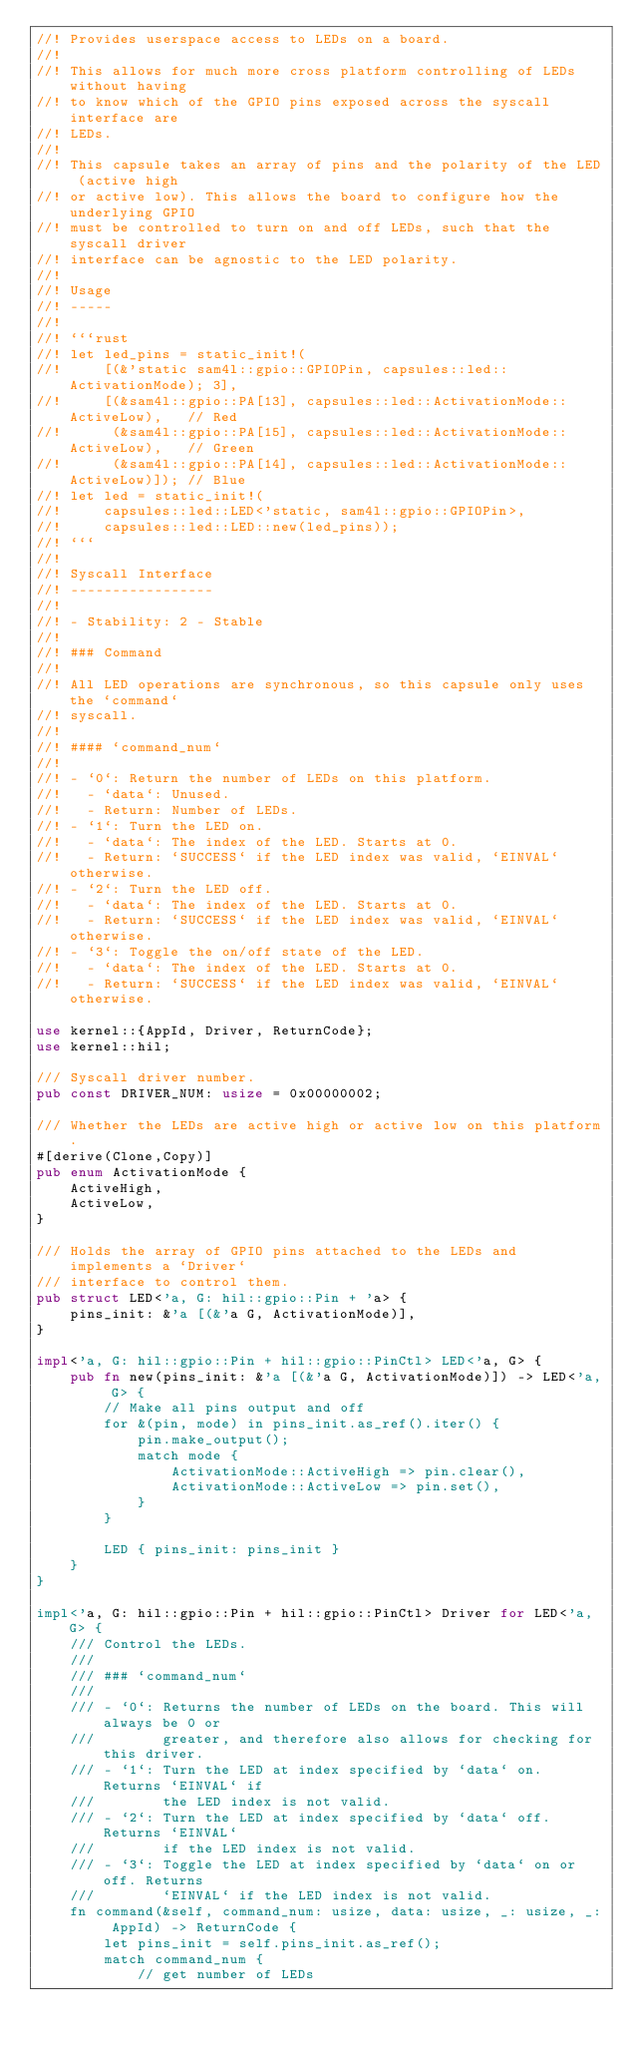Convert code to text. <code><loc_0><loc_0><loc_500><loc_500><_Rust_>//! Provides userspace access to LEDs on a board.
//!
//! This allows for much more cross platform controlling of LEDs without having
//! to know which of the GPIO pins exposed across the syscall interface are
//! LEDs.
//!
//! This capsule takes an array of pins and the polarity of the LED (active high
//! or active low). This allows the board to configure how the underlying GPIO
//! must be controlled to turn on and off LEDs, such that the syscall driver
//! interface can be agnostic to the LED polarity.
//!
//! Usage
//! -----
//!
//! ```rust
//! let led_pins = static_init!(
//!     [(&'static sam4l::gpio::GPIOPin, capsules::led::ActivationMode); 3],
//!     [(&sam4l::gpio::PA[13], capsules::led::ActivationMode::ActiveLow),   // Red
//!      (&sam4l::gpio::PA[15], capsules::led::ActivationMode::ActiveLow),   // Green
//!      (&sam4l::gpio::PA[14], capsules::led::ActivationMode::ActiveLow)]); // Blue
//! let led = static_init!(
//!     capsules::led::LED<'static, sam4l::gpio::GPIOPin>,
//!     capsules::led::LED::new(led_pins));
//! ```
//!
//! Syscall Interface
//! -----------------
//!
//! - Stability: 2 - Stable
//!
//! ### Command
//!
//! All LED operations are synchronous, so this capsule only uses the `command`
//! syscall.
//!
//! #### `command_num`
//!
//! - `0`: Return the number of LEDs on this platform.
//!   - `data`: Unused.
//!   - Return: Number of LEDs.
//! - `1`: Turn the LED on.
//!   - `data`: The index of the LED. Starts at 0.
//!   - Return: `SUCCESS` if the LED index was valid, `EINVAL` otherwise.
//! - `2`: Turn the LED off.
//!   - `data`: The index of the LED. Starts at 0.
//!   - Return: `SUCCESS` if the LED index was valid, `EINVAL` otherwise.
//! - `3`: Toggle the on/off state of the LED.
//!   - `data`: The index of the LED. Starts at 0.
//!   - Return: `SUCCESS` if the LED index was valid, `EINVAL` otherwise.

use kernel::{AppId, Driver, ReturnCode};
use kernel::hil;

/// Syscall driver number.
pub const DRIVER_NUM: usize = 0x00000002;

/// Whether the LEDs are active high or active low on this platform.
#[derive(Clone,Copy)]
pub enum ActivationMode {
    ActiveHigh,
    ActiveLow,
}

/// Holds the array of GPIO pins attached to the LEDs and implements a `Driver`
/// interface to control them.
pub struct LED<'a, G: hil::gpio::Pin + 'a> {
    pins_init: &'a [(&'a G, ActivationMode)],
}

impl<'a, G: hil::gpio::Pin + hil::gpio::PinCtl> LED<'a, G> {
    pub fn new(pins_init: &'a [(&'a G, ActivationMode)]) -> LED<'a, G> {
        // Make all pins output and off
        for &(pin, mode) in pins_init.as_ref().iter() {
            pin.make_output();
            match mode {
                ActivationMode::ActiveHigh => pin.clear(),
                ActivationMode::ActiveLow => pin.set(),
            }
        }

        LED { pins_init: pins_init }
    }
}

impl<'a, G: hil::gpio::Pin + hil::gpio::PinCtl> Driver for LED<'a, G> {
    /// Control the LEDs.
    ///
    /// ### `command_num`
    ///
    /// - `0`: Returns the number of LEDs on the board. This will always be 0 or
    ///        greater, and therefore also allows for checking for this driver.
    /// - `1`: Turn the LED at index specified by `data` on. Returns `EINVAL` if
    ///        the LED index is not valid.
    /// - `2`: Turn the LED at index specified by `data` off. Returns `EINVAL`
    ///        if the LED index is not valid.
    /// - `3`: Toggle the LED at index specified by `data` on or off. Returns
    ///        `EINVAL` if the LED index is not valid.
    fn command(&self, command_num: usize, data: usize, _: usize, _: AppId) -> ReturnCode {
        let pins_init = self.pins_init.as_ref();
        match command_num {
            // get number of LEDs</code> 